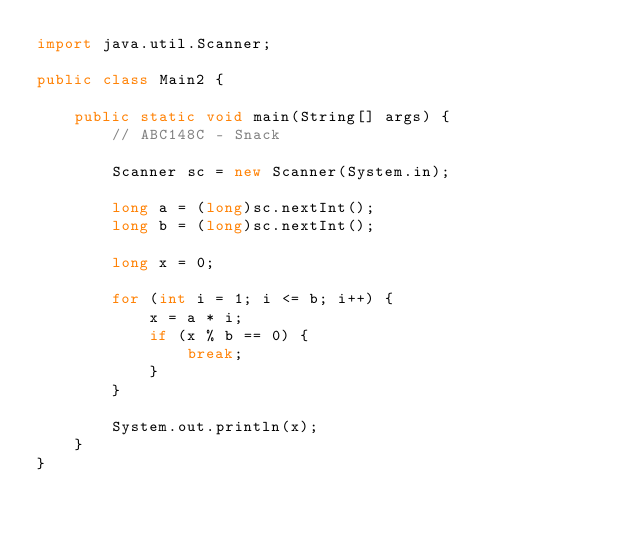Convert code to text. <code><loc_0><loc_0><loc_500><loc_500><_Java_>import java.util.Scanner;

public class Main2 {

    public static void main(String[] args) {
        // ABC148C - Snack

        Scanner sc = new Scanner(System.in);

        long a = (long)sc.nextInt();
        long b = (long)sc.nextInt();

        long x = 0;
        
        for (int i = 1; i <= b; i++) {
            x = a * i;
            if (x % b == 0) {
                break;
            }
        }
        
        System.out.println(x);
    }
}
</code> 